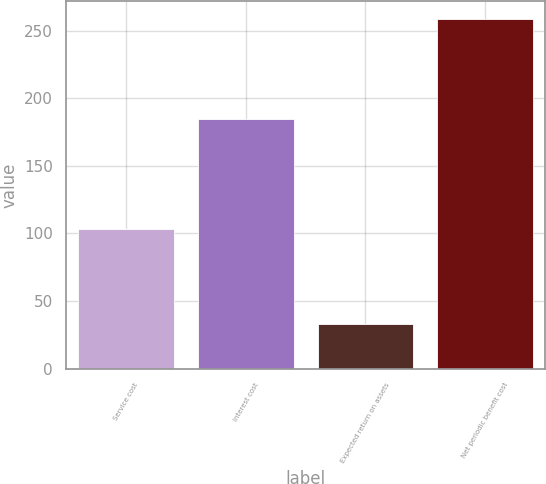<chart> <loc_0><loc_0><loc_500><loc_500><bar_chart><fcel>Service cost<fcel>Interest cost<fcel>Expected return on assets<fcel>Net periodic benefit cost<nl><fcel>103<fcel>185<fcel>33<fcel>259<nl></chart> 